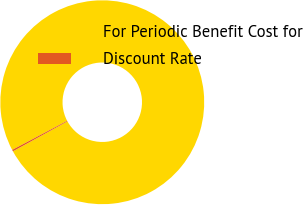Convert chart to OTSL. <chart><loc_0><loc_0><loc_500><loc_500><pie_chart><fcel>For Periodic Benefit Cost for<fcel>Discount Rate<nl><fcel>99.75%<fcel>0.25%<nl></chart> 